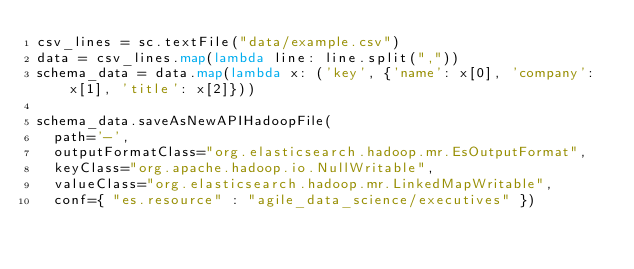<code> <loc_0><loc_0><loc_500><loc_500><_Python_>csv_lines = sc.textFile("data/example.csv")
data = csv_lines.map(lambda line: line.split(","))
schema_data = data.map(lambda x: ('key', {'name': x[0], 'company': x[1], 'title': x[2]}))

schema_data.saveAsNewAPIHadoopFile(
  path='-', 
  outputFormatClass="org.elasticsearch.hadoop.mr.EsOutputFormat",
  keyClass="org.apache.hadoop.io.NullWritable", 
  valueClass="org.elasticsearch.hadoop.mr.LinkedMapWritable", 
  conf={ "es.resource" : "agile_data_science/executives" })
</code> 